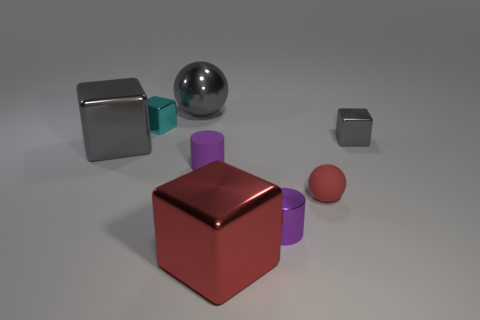There is a gray metallic thing that is left of the big sphere; what is its size? The gray metallic object to the left of the large sphere appears to be a medium-sized cube, if we compare it to the sphere and other objects in the scene. It's smaller than the central red cube but larger than the small gray cube in the distance. 